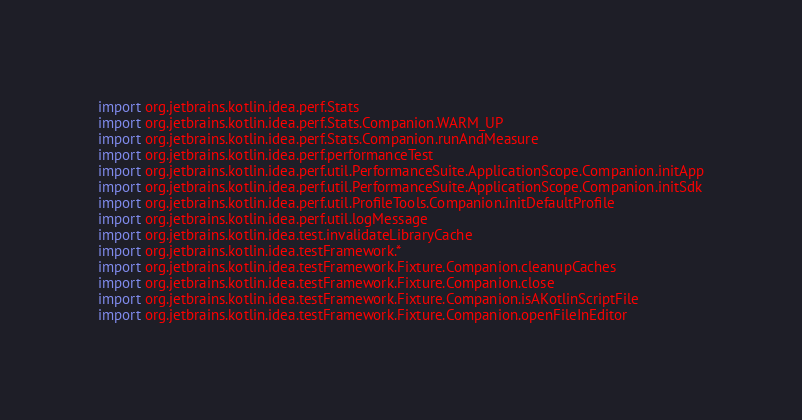<code> <loc_0><loc_0><loc_500><loc_500><_Kotlin_>import org.jetbrains.kotlin.idea.perf.Stats
import org.jetbrains.kotlin.idea.perf.Stats.Companion.WARM_UP
import org.jetbrains.kotlin.idea.perf.Stats.Companion.runAndMeasure
import org.jetbrains.kotlin.idea.perf.performanceTest
import org.jetbrains.kotlin.idea.perf.util.PerformanceSuite.ApplicationScope.Companion.initApp
import org.jetbrains.kotlin.idea.perf.util.PerformanceSuite.ApplicationScope.Companion.initSdk
import org.jetbrains.kotlin.idea.perf.util.ProfileTools.Companion.initDefaultProfile
import org.jetbrains.kotlin.idea.perf.util.logMessage
import org.jetbrains.kotlin.idea.test.invalidateLibraryCache
import org.jetbrains.kotlin.idea.testFramework.*
import org.jetbrains.kotlin.idea.testFramework.Fixture.Companion.cleanupCaches
import org.jetbrains.kotlin.idea.testFramework.Fixture.Companion.close
import org.jetbrains.kotlin.idea.testFramework.Fixture.Companion.isAKotlinScriptFile
import org.jetbrains.kotlin.idea.testFramework.Fixture.Companion.openFileInEditor</code> 